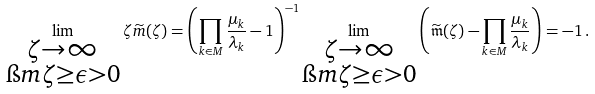Convert formula to latex. <formula><loc_0><loc_0><loc_500><loc_500>\lim _ { \substack { \zeta \to \infty \\ \i m \zeta \geq \epsilon > 0 } } \zeta \widetilde { m } ( \zeta ) = \left ( \prod _ { k \in M } \frac { \mu _ { k } } { \lambda _ { k } } - 1 \right ) ^ { - 1 } \lim _ { \substack { \zeta \to \infty \\ \i m \zeta \geq \epsilon > 0 } } \left ( \widetilde { \mathfrak { m } } ( \zeta ) - \prod _ { k \in M } \frac { \mu _ { k } } { \lambda _ { k } } \right ) = - 1 \, .</formula> 